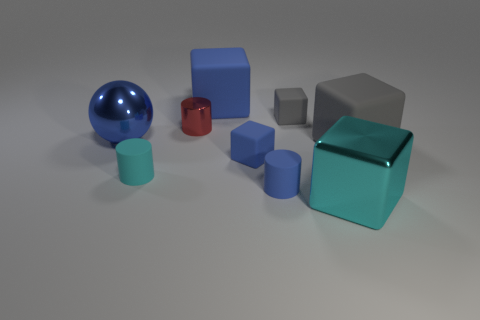Describe the color variety among the objects in the image. The image showcases a diverse palette with each object having its own unique color. There's a shiny blue sphere, a metallic cube with a highly reflective surface, a red glossy cube, and several other cubes in various shades of blue and gray. 